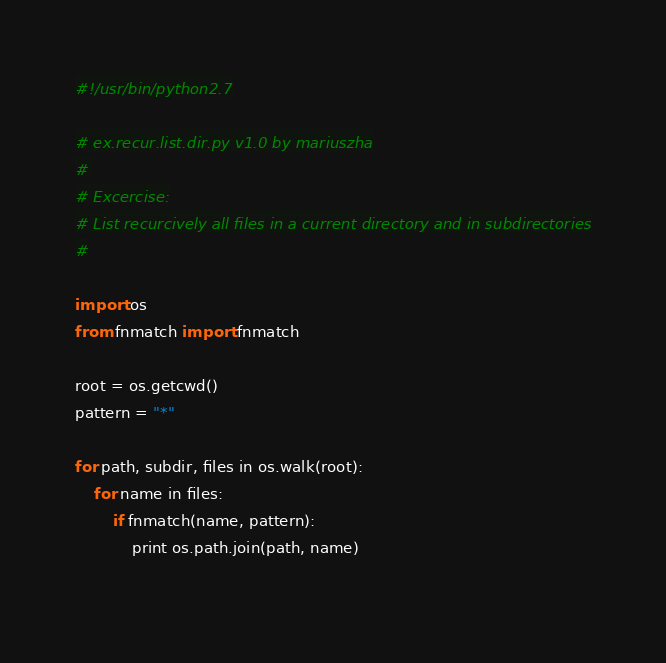Convert code to text. <code><loc_0><loc_0><loc_500><loc_500><_Python_>#!/usr/bin/python2.7

# ex.recur.list.dir.py v1.0 by mariuszha
# 
# Excercise:
# List recurcively all files in a current directory and in subdirectories
#

import os
from fnmatch import fnmatch

root = os.getcwd()
pattern = "*"

for path, subdir, files in os.walk(root):
	for name in files:
		if fnmatch(name, pattern):
			print os.path.join(path, name)
      
</code> 